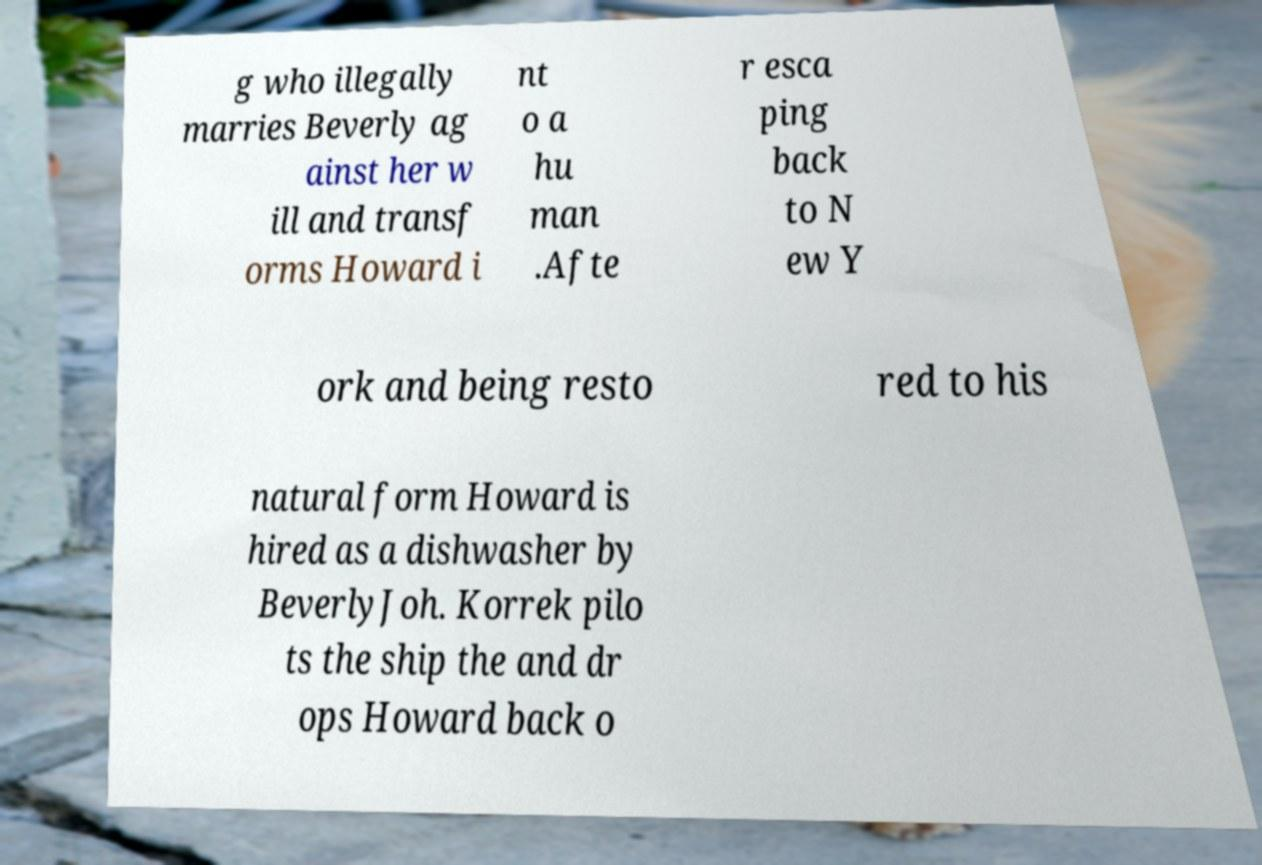For documentation purposes, I need the text within this image transcribed. Could you provide that? g who illegally marries Beverly ag ainst her w ill and transf orms Howard i nt o a hu man .Afte r esca ping back to N ew Y ork and being resto red to his natural form Howard is hired as a dishwasher by BeverlyJoh. Korrek pilo ts the ship the and dr ops Howard back o 